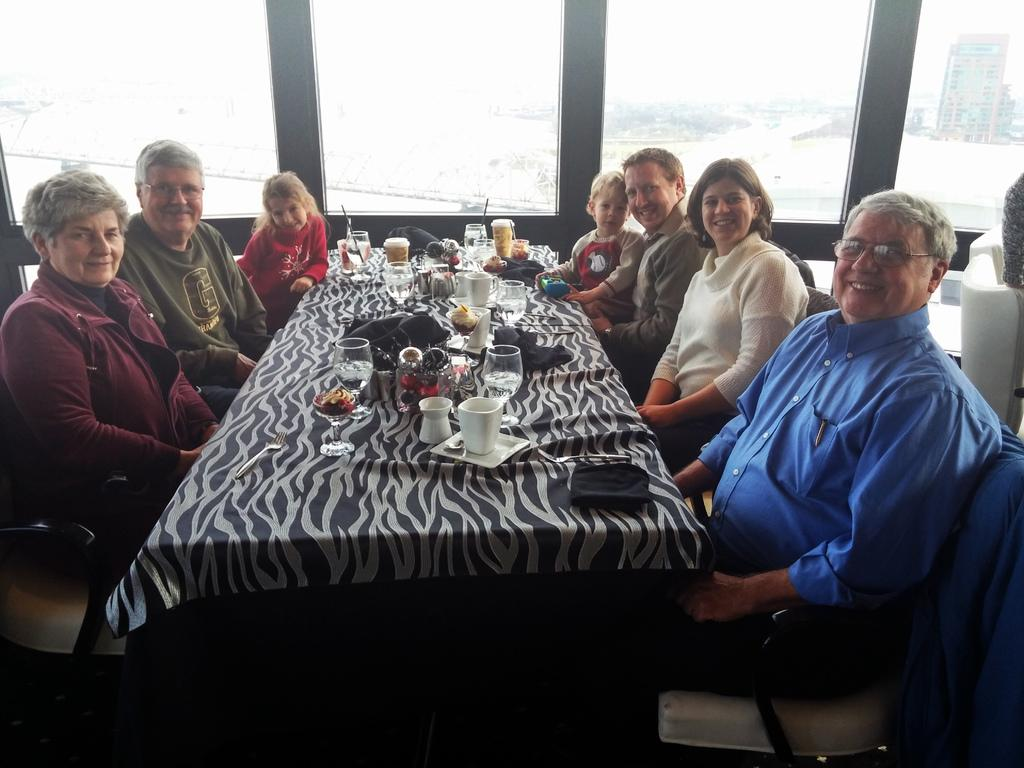Who is present in the image? There is a family in the image. What are the family members doing in the image? The family is having food. What type of reaction can be seen from the family when they are presented with a pickle in the image? There is no pickle present in the image, so it is not possible to determine any reactions related to it. 